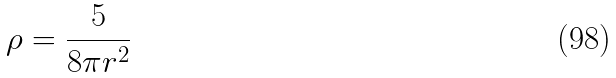Convert formula to latex. <formula><loc_0><loc_0><loc_500><loc_500>\rho = \frac { 5 } { 8 \pi r ^ { 2 } }</formula> 